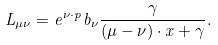Convert formula to latex. <formula><loc_0><loc_0><loc_500><loc_500>L _ { \mu \nu } = e ^ { \nu \cdot p } b _ { \nu } \frac { \gamma } { ( \mu - \nu ) \cdot x + \gamma } .</formula> 